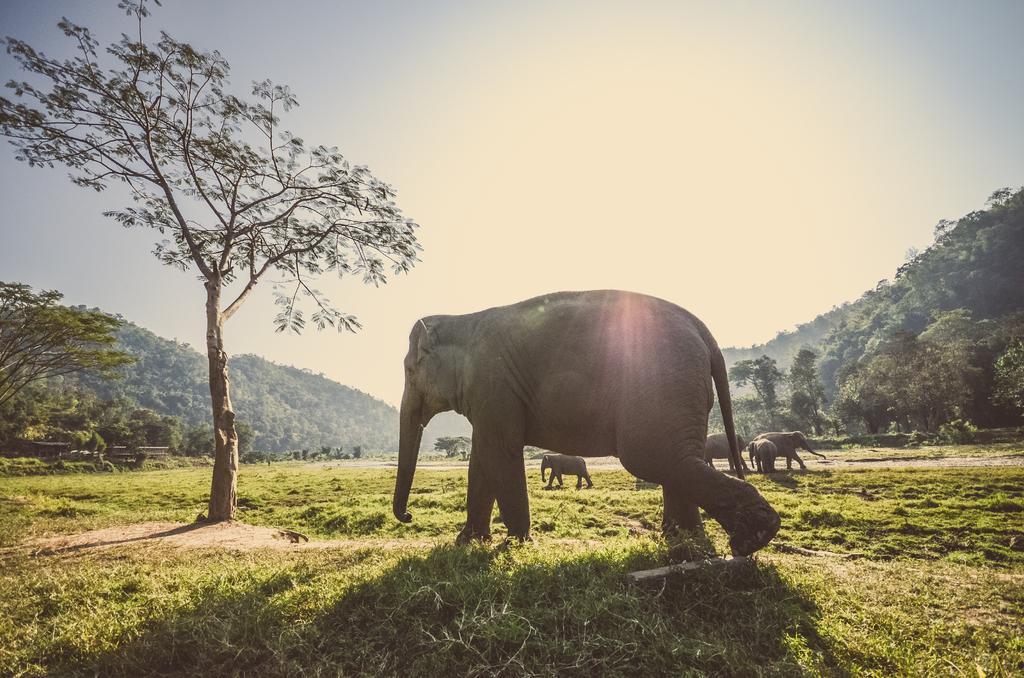How would you summarize this image in a sentence or two? In this picture we can see a group of elephants walking on the ground, grass, trees, mountains and in the background we can see the sky. 